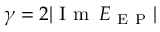<formula> <loc_0><loc_0><loc_500><loc_500>\gamma = 2 | I m \, E _ { E P } |</formula> 